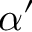Convert formula to latex. <formula><loc_0><loc_0><loc_500><loc_500>\alpha ^ { \prime }</formula> 